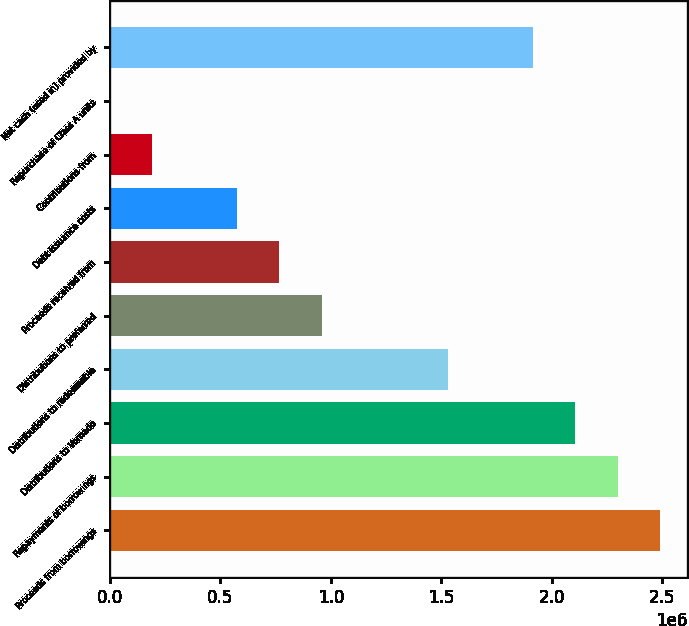Convert chart to OTSL. <chart><loc_0><loc_0><loc_500><loc_500><bar_chart><fcel>Proceeds from borrowings<fcel>Repayments of borrowings<fcel>Distributions to Vornado<fcel>Distributions to redeemable<fcel>Distributions to preferred<fcel>Proceeds received from<fcel>Debt issuance costs<fcel>Contributions from<fcel>Repurchase of Class A units<fcel>Net cash (used in) provided by<nl><fcel>2.48913e+06<fcel>2.29769e+06<fcel>2.10625e+06<fcel>1.53193e+06<fcel>957615<fcel>766176<fcel>574736<fcel>191857<fcel>418<fcel>1.91481e+06<nl></chart> 